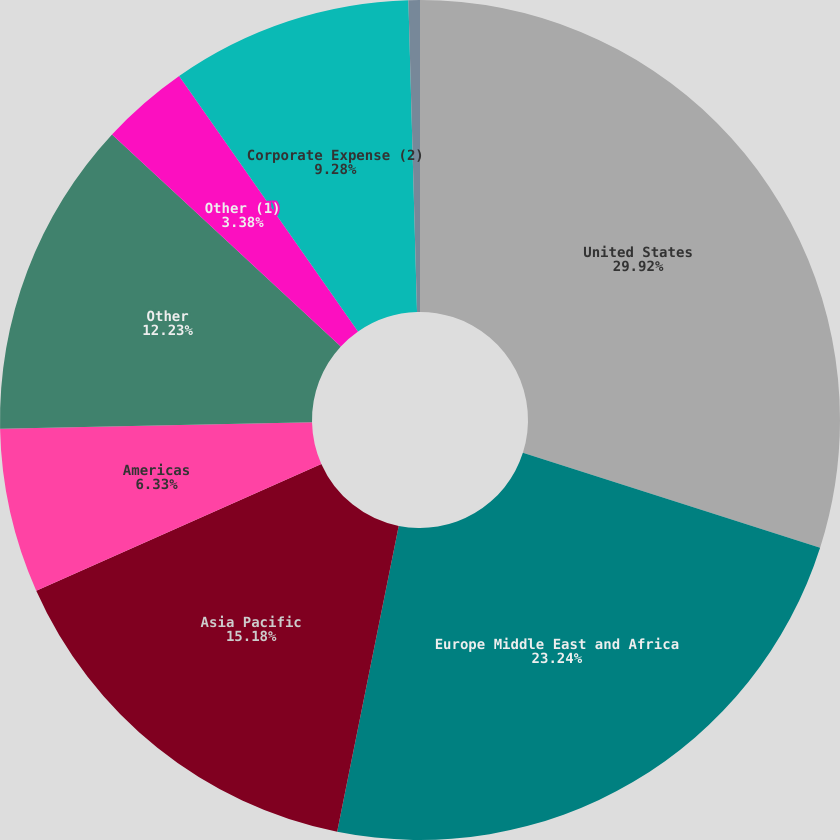Convert chart. <chart><loc_0><loc_0><loc_500><loc_500><pie_chart><fcel>United States<fcel>Europe Middle East and Africa<fcel>Asia Pacific<fcel>Americas<fcel>Other<fcel>Other (1)<fcel>Corporate Expense (2)<fcel>Corporate<nl><fcel>29.92%<fcel>23.24%<fcel>15.18%<fcel>6.33%<fcel>12.23%<fcel>3.38%<fcel>9.28%<fcel>0.44%<nl></chart> 